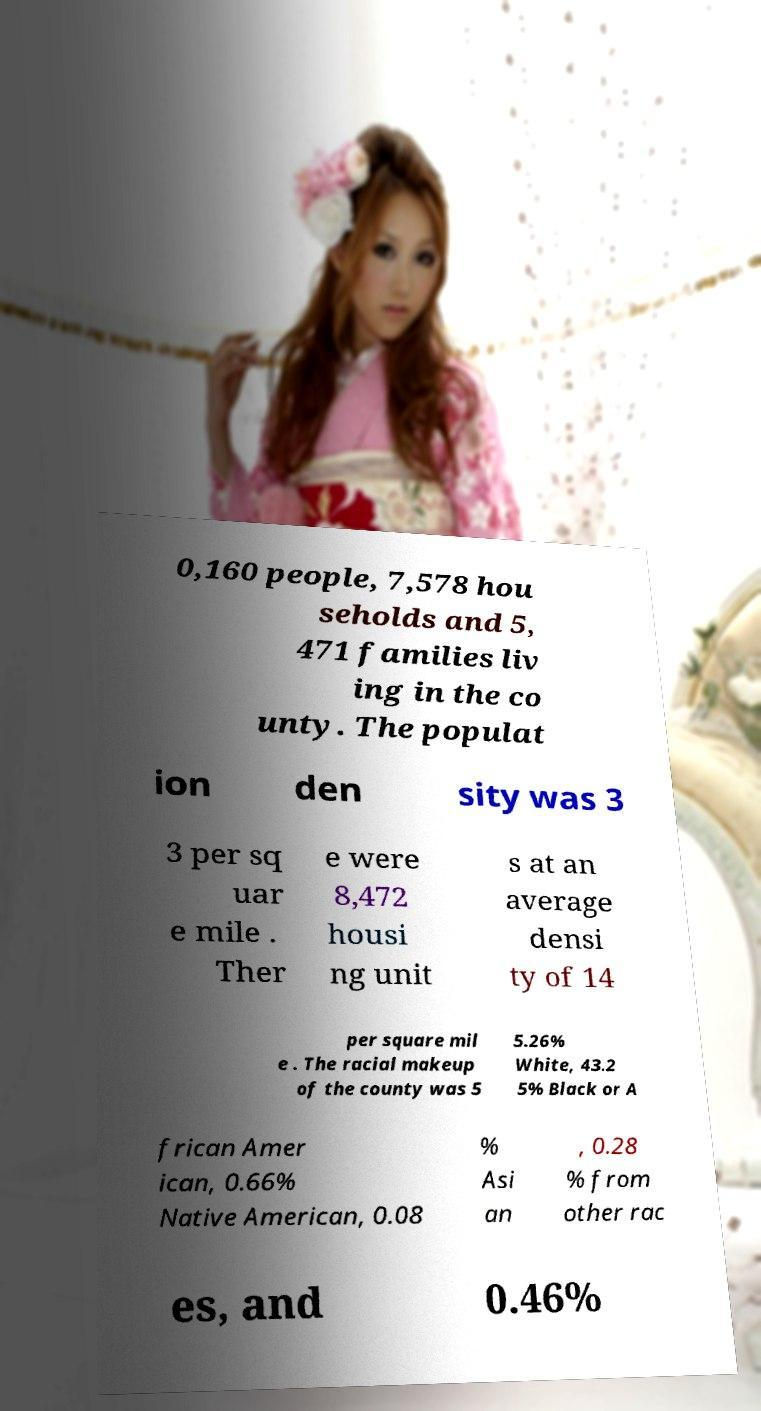Can you accurately transcribe the text from the provided image for me? 0,160 people, 7,578 hou seholds and 5, 471 families liv ing in the co unty. The populat ion den sity was 3 3 per sq uar e mile . Ther e were 8,472 housi ng unit s at an average densi ty of 14 per square mil e . The racial makeup of the county was 5 5.26% White, 43.2 5% Black or A frican Amer ican, 0.66% Native American, 0.08 % Asi an , 0.28 % from other rac es, and 0.46% 